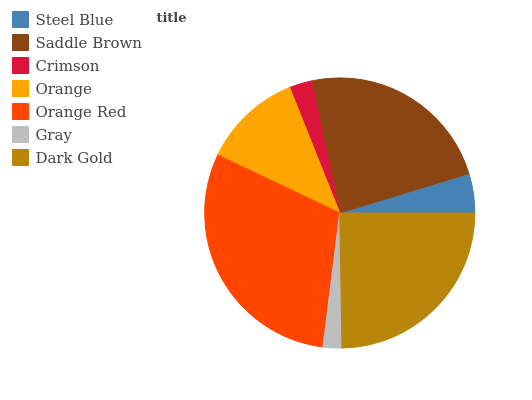Is Gray the minimum?
Answer yes or no. Yes. Is Orange Red the maximum?
Answer yes or no. Yes. Is Saddle Brown the minimum?
Answer yes or no. No. Is Saddle Brown the maximum?
Answer yes or no. No. Is Saddle Brown greater than Steel Blue?
Answer yes or no. Yes. Is Steel Blue less than Saddle Brown?
Answer yes or no. Yes. Is Steel Blue greater than Saddle Brown?
Answer yes or no. No. Is Saddle Brown less than Steel Blue?
Answer yes or no. No. Is Orange the high median?
Answer yes or no. Yes. Is Orange the low median?
Answer yes or no. Yes. Is Saddle Brown the high median?
Answer yes or no. No. Is Crimson the low median?
Answer yes or no. No. 